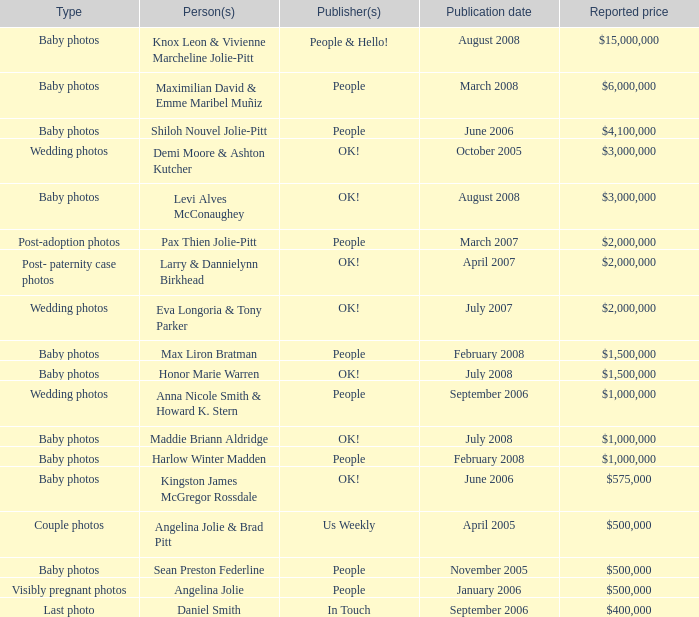What variety of angelina jolie photographs are worth $500,000? Visibly pregnant photos. 